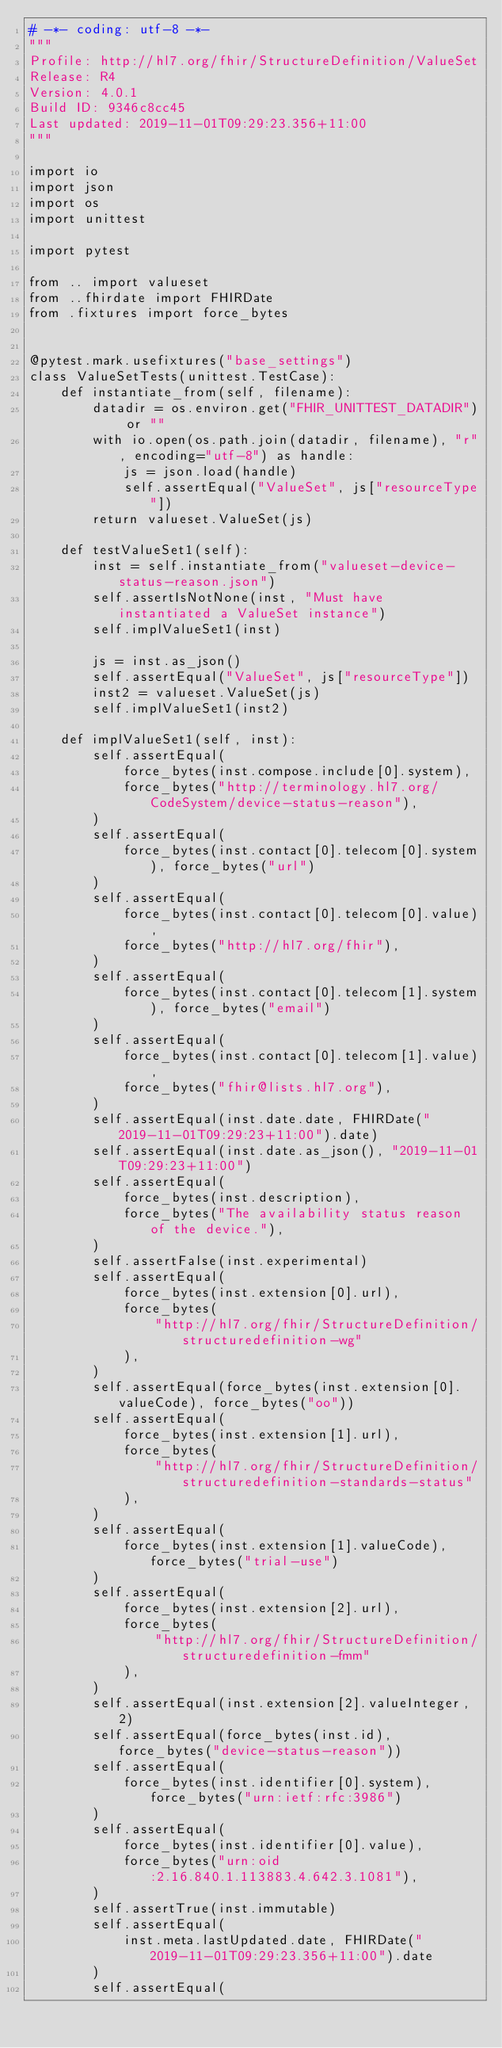<code> <loc_0><loc_0><loc_500><loc_500><_Python_># -*- coding: utf-8 -*-
"""
Profile: http://hl7.org/fhir/StructureDefinition/ValueSet
Release: R4
Version: 4.0.1
Build ID: 9346c8cc45
Last updated: 2019-11-01T09:29:23.356+11:00
"""

import io
import json
import os
import unittest

import pytest

from .. import valueset
from ..fhirdate import FHIRDate
from .fixtures import force_bytes


@pytest.mark.usefixtures("base_settings")
class ValueSetTests(unittest.TestCase):
    def instantiate_from(self, filename):
        datadir = os.environ.get("FHIR_UNITTEST_DATADIR") or ""
        with io.open(os.path.join(datadir, filename), "r", encoding="utf-8") as handle:
            js = json.load(handle)
            self.assertEqual("ValueSet", js["resourceType"])
        return valueset.ValueSet(js)

    def testValueSet1(self):
        inst = self.instantiate_from("valueset-device-status-reason.json")
        self.assertIsNotNone(inst, "Must have instantiated a ValueSet instance")
        self.implValueSet1(inst)

        js = inst.as_json()
        self.assertEqual("ValueSet", js["resourceType"])
        inst2 = valueset.ValueSet(js)
        self.implValueSet1(inst2)

    def implValueSet1(self, inst):
        self.assertEqual(
            force_bytes(inst.compose.include[0].system),
            force_bytes("http://terminology.hl7.org/CodeSystem/device-status-reason"),
        )
        self.assertEqual(
            force_bytes(inst.contact[0].telecom[0].system), force_bytes("url")
        )
        self.assertEqual(
            force_bytes(inst.contact[0].telecom[0].value),
            force_bytes("http://hl7.org/fhir"),
        )
        self.assertEqual(
            force_bytes(inst.contact[0].telecom[1].system), force_bytes("email")
        )
        self.assertEqual(
            force_bytes(inst.contact[0].telecom[1].value),
            force_bytes("fhir@lists.hl7.org"),
        )
        self.assertEqual(inst.date.date, FHIRDate("2019-11-01T09:29:23+11:00").date)
        self.assertEqual(inst.date.as_json(), "2019-11-01T09:29:23+11:00")
        self.assertEqual(
            force_bytes(inst.description),
            force_bytes("The availability status reason of the device."),
        )
        self.assertFalse(inst.experimental)
        self.assertEqual(
            force_bytes(inst.extension[0].url),
            force_bytes(
                "http://hl7.org/fhir/StructureDefinition/structuredefinition-wg"
            ),
        )
        self.assertEqual(force_bytes(inst.extension[0].valueCode), force_bytes("oo"))
        self.assertEqual(
            force_bytes(inst.extension[1].url),
            force_bytes(
                "http://hl7.org/fhir/StructureDefinition/structuredefinition-standards-status"
            ),
        )
        self.assertEqual(
            force_bytes(inst.extension[1].valueCode), force_bytes("trial-use")
        )
        self.assertEqual(
            force_bytes(inst.extension[2].url),
            force_bytes(
                "http://hl7.org/fhir/StructureDefinition/structuredefinition-fmm"
            ),
        )
        self.assertEqual(inst.extension[2].valueInteger, 2)
        self.assertEqual(force_bytes(inst.id), force_bytes("device-status-reason"))
        self.assertEqual(
            force_bytes(inst.identifier[0].system), force_bytes("urn:ietf:rfc:3986")
        )
        self.assertEqual(
            force_bytes(inst.identifier[0].value),
            force_bytes("urn:oid:2.16.840.1.113883.4.642.3.1081"),
        )
        self.assertTrue(inst.immutable)
        self.assertEqual(
            inst.meta.lastUpdated.date, FHIRDate("2019-11-01T09:29:23.356+11:00").date
        )
        self.assertEqual(</code> 